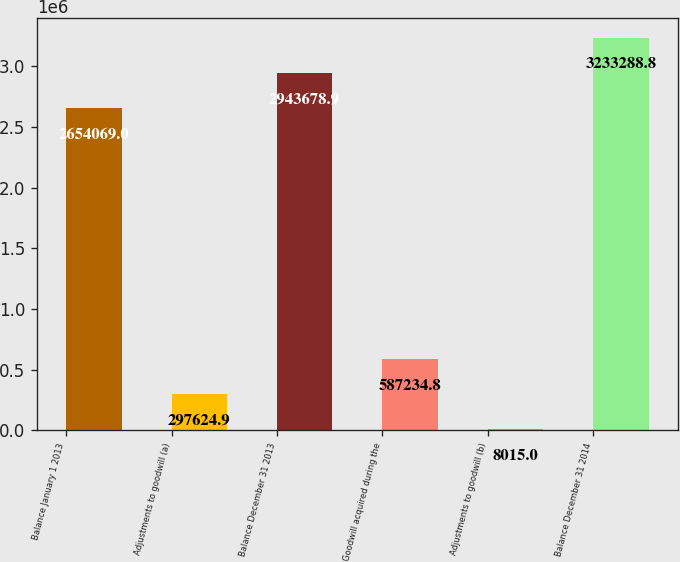<chart> <loc_0><loc_0><loc_500><loc_500><bar_chart><fcel>Balance January 1 2013<fcel>Adjustments to goodwill (a)<fcel>Balance December 31 2013<fcel>Goodwill acquired during the<fcel>Adjustments to goodwill (b)<fcel>Balance December 31 2014<nl><fcel>2.65407e+06<fcel>297625<fcel>2.94368e+06<fcel>587235<fcel>8015<fcel>3.23329e+06<nl></chart> 